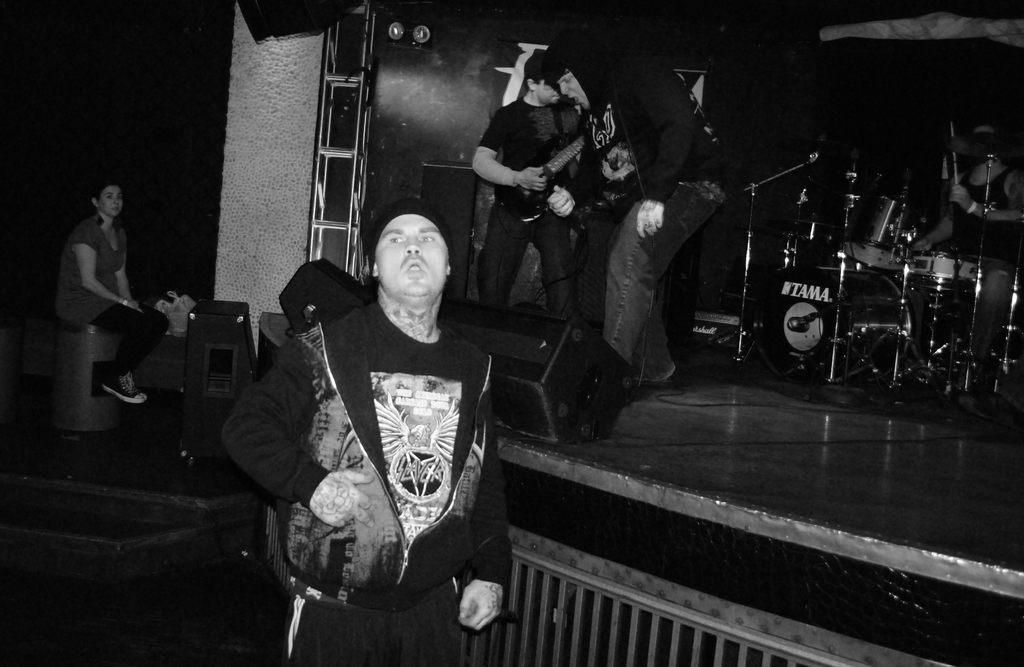How would you summarize this image in a sentence or two? In the image we can see there are people standing on the stage and they are playing musical instruments. There is a drum set kept at the back and in front there is a man standing and he is wearing jacket. There is a woman sitting on the speaker box and the image is in black and white colour. 